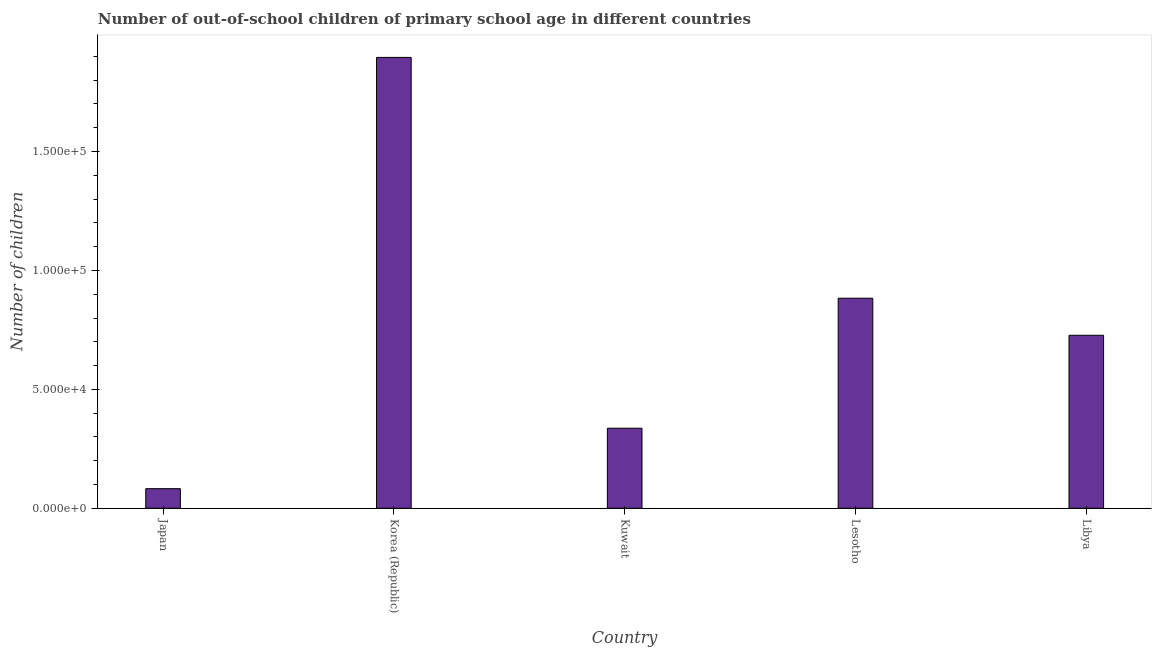Does the graph contain grids?
Provide a short and direct response. No. What is the title of the graph?
Make the answer very short. Number of out-of-school children of primary school age in different countries. What is the label or title of the Y-axis?
Keep it short and to the point. Number of children. What is the number of out-of-school children in Lesotho?
Offer a terse response. 8.83e+04. Across all countries, what is the maximum number of out-of-school children?
Your answer should be compact. 1.90e+05. Across all countries, what is the minimum number of out-of-school children?
Your answer should be very brief. 8238. In which country was the number of out-of-school children maximum?
Keep it short and to the point. Korea (Republic). In which country was the number of out-of-school children minimum?
Offer a terse response. Japan. What is the sum of the number of out-of-school children?
Your response must be concise. 3.93e+05. What is the difference between the number of out-of-school children in Korea (Republic) and Lesotho?
Provide a succinct answer. 1.01e+05. What is the average number of out-of-school children per country?
Provide a succinct answer. 7.85e+04. What is the median number of out-of-school children?
Ensure brevity in your answer.  7.27e+04. In how many countries, is the number of out-of-school children greater than 10000 ?
Ensure brevity in your answer.  4. What is the ratio of the number of out-of-school children in Kuwait to that in Lesotho?
Ensure brevity in your answer.  0.38. Is the number of out-of-school children in Japan less than that in Libya?
Offer a very short reply. Yes. Is the difference between the number of out-of-school children in Korea (Republic) and Libya greater than the difference between any two countries?
Ensure brevity in your answer.  No. What is the difference between the highest and the second highest number of out-of-school children?
Make the answer very short. 1.01e+05. What is the difference between the highest and the lowest number of out-of-school children?
Your answer should be compact. 1.81e+05. How many countries are there in the graph?
Provide a short and direct response. 5. What is the Number of children of Japan?
Offer a very short reply. 8238. What is the Number of children in Korea (Republic)?
Offer a terse response. 1.90e+05. What is the Number of children of Kuwait?
Provide a short and direct response. 3.37e+04. What is the Number of children of Lesotho?
Offer a terse response. 8.83e+04. What is the Number of children of Libya?
Keep it short and to the point. 7.27e+04. What is the difference between the Number of children in Japan and Korea (Republic)?
Offer a very short reply. -1.81e+05. What is the difference between the Number of children in Japan and Kuwait?
Ensure brevity in your answer.  -2.54e+04. What is the difference between the Number of children in Japan and Lesotho?
Provide a short and direct response. -8.01e+04. What is the difference between the Number of children in Japan and Libya?
Provide a short and direct response. -6.45e+04. What is the difference between the Number of children in Korea (Republic) and Kuwait?
Keep it short and to the point. 1.56e+05. What is the difference between the Number of children in Korea (Republic) and Lesotho?
Your answer should be very brief. 1.01e+05. What is the difference between the Number of children in Korea (Republic) and Libya?
Your answer should be very brief. 1.17e+05. What is the difference between the Number of children in Kuwait and Lesotho?
Offer a very short reply. -5.47e+04. What is the difference between the Number of children in Kuwait and Libya?
Ensure brevity in your answer.  -3.91e+04. What is the difference between the Number of children in Lesotho and Libya?
Ensure brevity in your answer.  1.56e+04. What is the ratio of the Number of children in Japan to that in Korea (Republic)?
Your response must be concise. 0.04. What is the ratio of the Number of children in Japan to that in Kuwait?
Ensure brevity in your answer.  0.24. What is the ratio of the Number of children in Japan to that in Lesotho?
Give a very brief answer. 0.09. What is the ratio of the Number of children in Japan to that in Libya?
Ensure brevity in your answer.  0.11. What is the ratio of the Number of children in Korea (Republic) to that in Kuwait?
Keep it short and to the point. 5.63. What is the ratio of the Number of children in Korea (Republic) to that in Lesotho?
Your answer should be compact. 2.15. What is the ratio of the Number of children in Korea (Republic) to that in Libya?
Offer a very short reply. 2.61. What is the ratio of the Number of children in Kuwait to that in Lesotho?
Offer a terse response. 0.38. What is the ratio of the Number of children in Kuwait to that in Libya?
Give a very brief answer. 0.46. What is the ratio of the Number of children in Lesotho to that in Libya?
Offer a terse response. 1.21. 